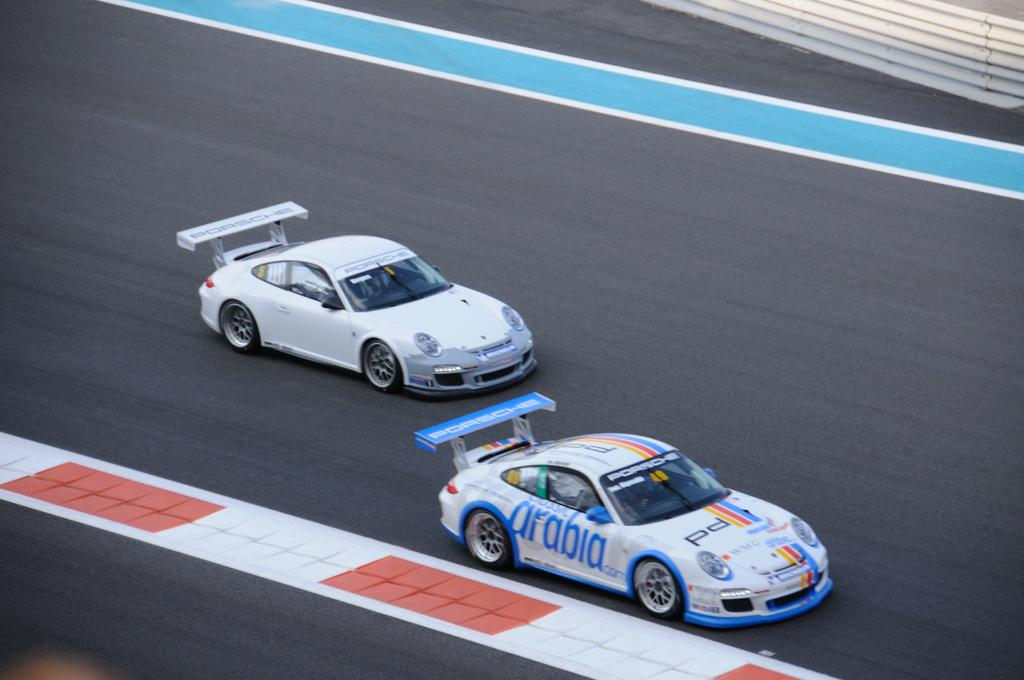What are the main subjects in the image? There are two racing cars in the image. Where are the racing cars located? The racing cars are on a racing track. What can be seen on the right side of the image? There is a railing on the right side of the image. What religion is being practiced by the racing cars in the image? The image does not depict any religious practices or beliefs; it features racing cars on a track. 